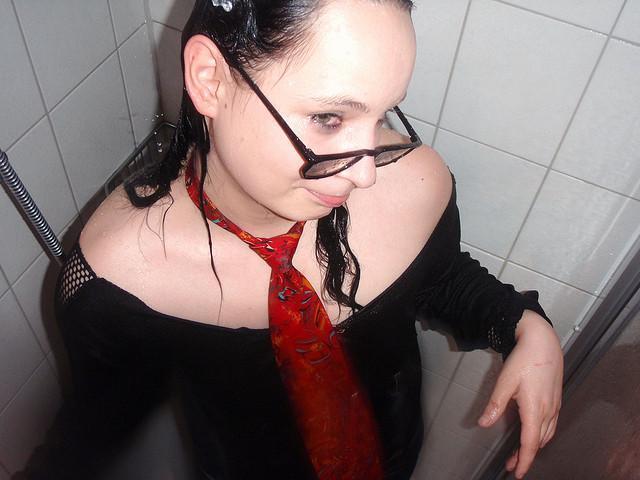How many cars have a surfboard on them?
Give a very brief answer. 0. 